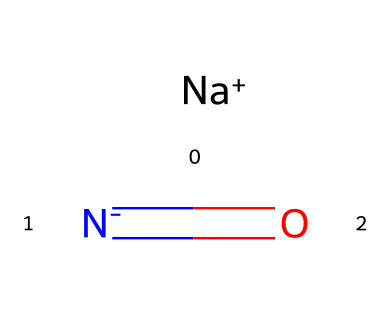what is the molecular formula of sodium nitrite? The SMILES representation indicates the presence of a sodium ion (Na+) and a nitrite ion (NO2-) with one nitrogen and two oxygen atoms. Therefore, the molecular formula can be derived as NaNO2.
Answer: NaNO2 how many atoms are present in sodium nitrite? From the representation, there is one sodium atom, one nitrogen atom, and two oxygen atoms, totaling four atoms combined.
Answer: 4 what type of bond is present between nitrogen and oxygen? The SMILES shows a nitrogen atom bonded to two oxygen atoms. This indicates that the nitrogen has a double bond with one oxygen (N=O) and a single bond with the other oxygen, which results in coordinating covalent bonds.
Answer: covalent what is the charge of the sodium ion in sodium nitrite? The SMILES notation shows [Na+], indicating that sodium has a positive charge of +1.
Answer: +1 how does sodium nitrite preserve meat? Sodium nitrite prevents the growth of bacteria, especially Clostridium botulinum, by inhibiting their metabolic processes, which extends the shelf life of preserved meat.
Answer: inhibits bacteria what role does the nitrogen atom play in sodium nitrite? The nitrogen atom in sodium nitrite contributes to the chemical's overall effect as a preservative by forming nitroso compounds, which have antimicrobial properties.
Answer: preservative作用 what is the physical state of sodium nitrite at room temperature? Sodium nitrite is typically found as a crystalline solid at room temperature, indicating its structural stability in that state.
Answer: solid 